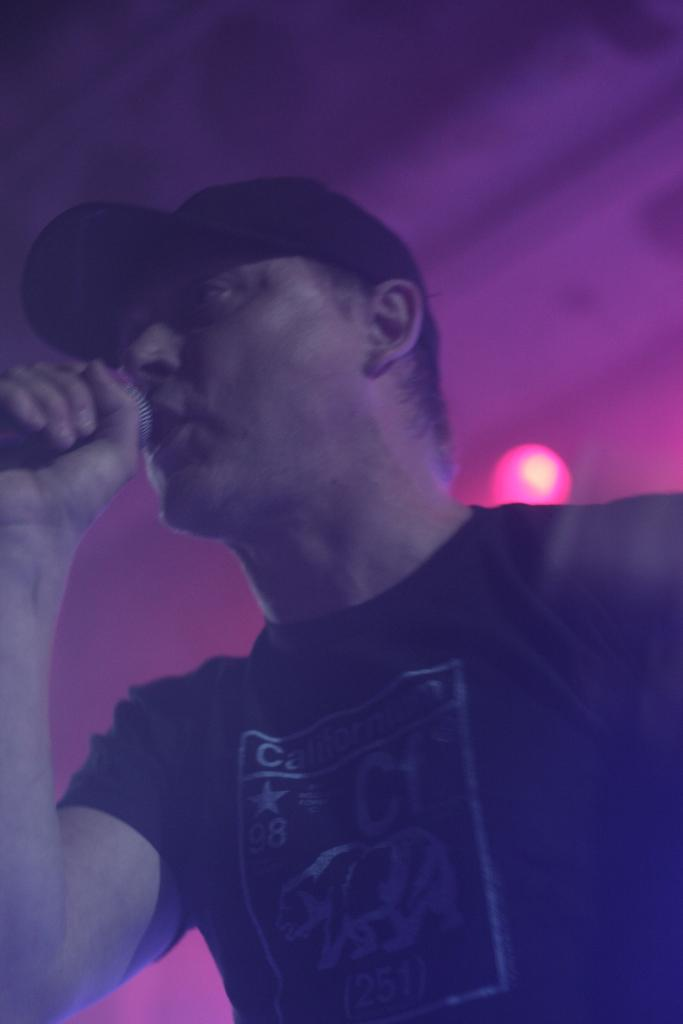What is the main subject of the image? There is a man in the image. What is the man wearing on his upper body? The man is wearing a black t-shirt. What is the man wearing on his head? The man is wearing a black cap. What object is the man holding in the image? The man is holding a microphone. What color can be seen in the background of the image? There is a purple color in the background of the image. Can you tell me how many deer are visible in the image? There are no deer present in the image. What type of sweater is the man wearing in the image? The man is not wearing a sweater in the image; he is wearing a black t-shirt. 